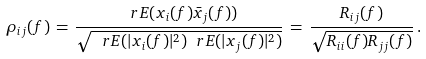<formula> <loc_0><loc_0><loc_500><loc_500>\rho _ { i j } ( f ) \, = \, \frac { \ r E ( x _ { i } ( f ) \bar { x } _ { j } ( f ) ) } { \sqrt { \ r E ( | x _ { i } ( f ) | ^ { 2 } ) \ r E ( | x _ { j } ( f ) | ^ { 2 } ) } } \, = \, \frac { R _ { i j } ( f ) } { \sqrt { R _ { i i } ( f ) R _ { j j } ( f ) } } \, .</formula> 